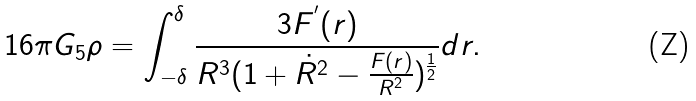<formula> <loc_0><loc_0><loc_500><loc_500>1 6 \pi G _ { 5 } \rho = \int _ { - \delta } ^ { \delta } \frac { 3 F ^ { ^ { \prime } } ( r ) } { R ^ { 3 } ( 1 + \dot { R } ^ { 2 } - \frac { F ( r ) } { R ^ { 2 } } ) ^ { \frac { 1 } { 2 } } } d r .</formula> 